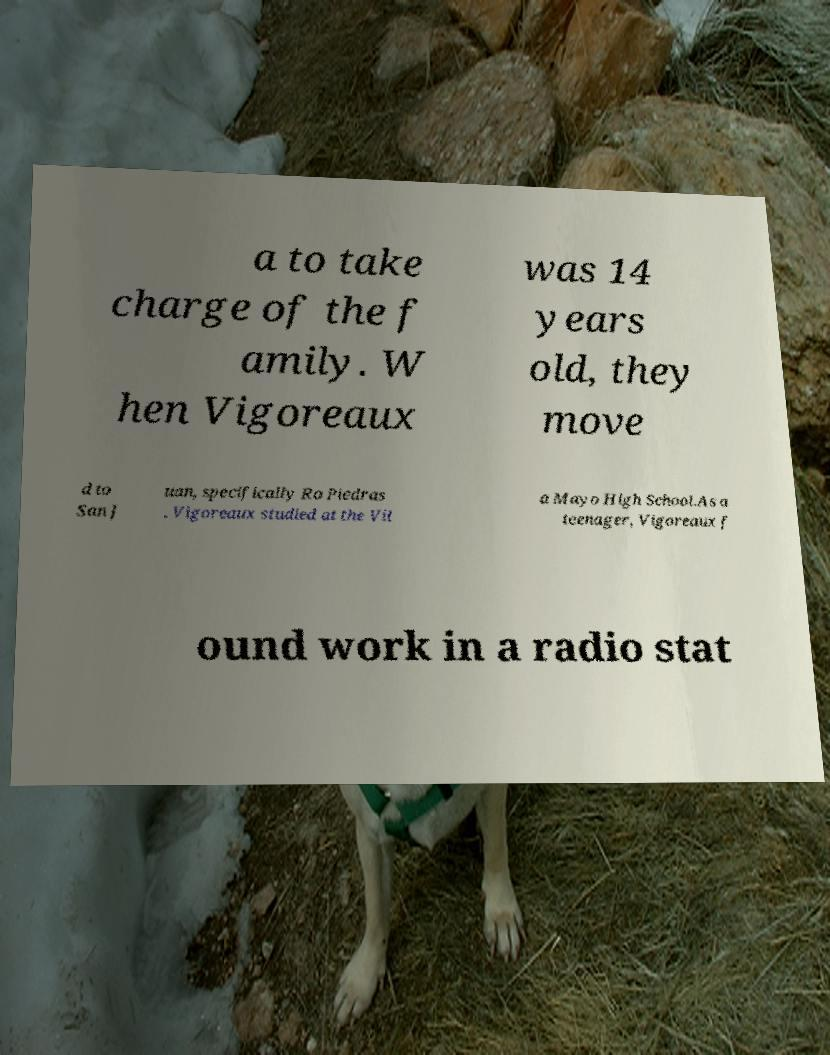Can you accurately transcribe the text from the provided image for me? a to take charge of the f amily. W hen Vigoreaux was 14 years old, they move d to San J uan, specifically Ro Piedras . Vigoreaux studied at the Vil a Mayo High School.As a teenager, Vigoreaux f ound work in a radio stat 